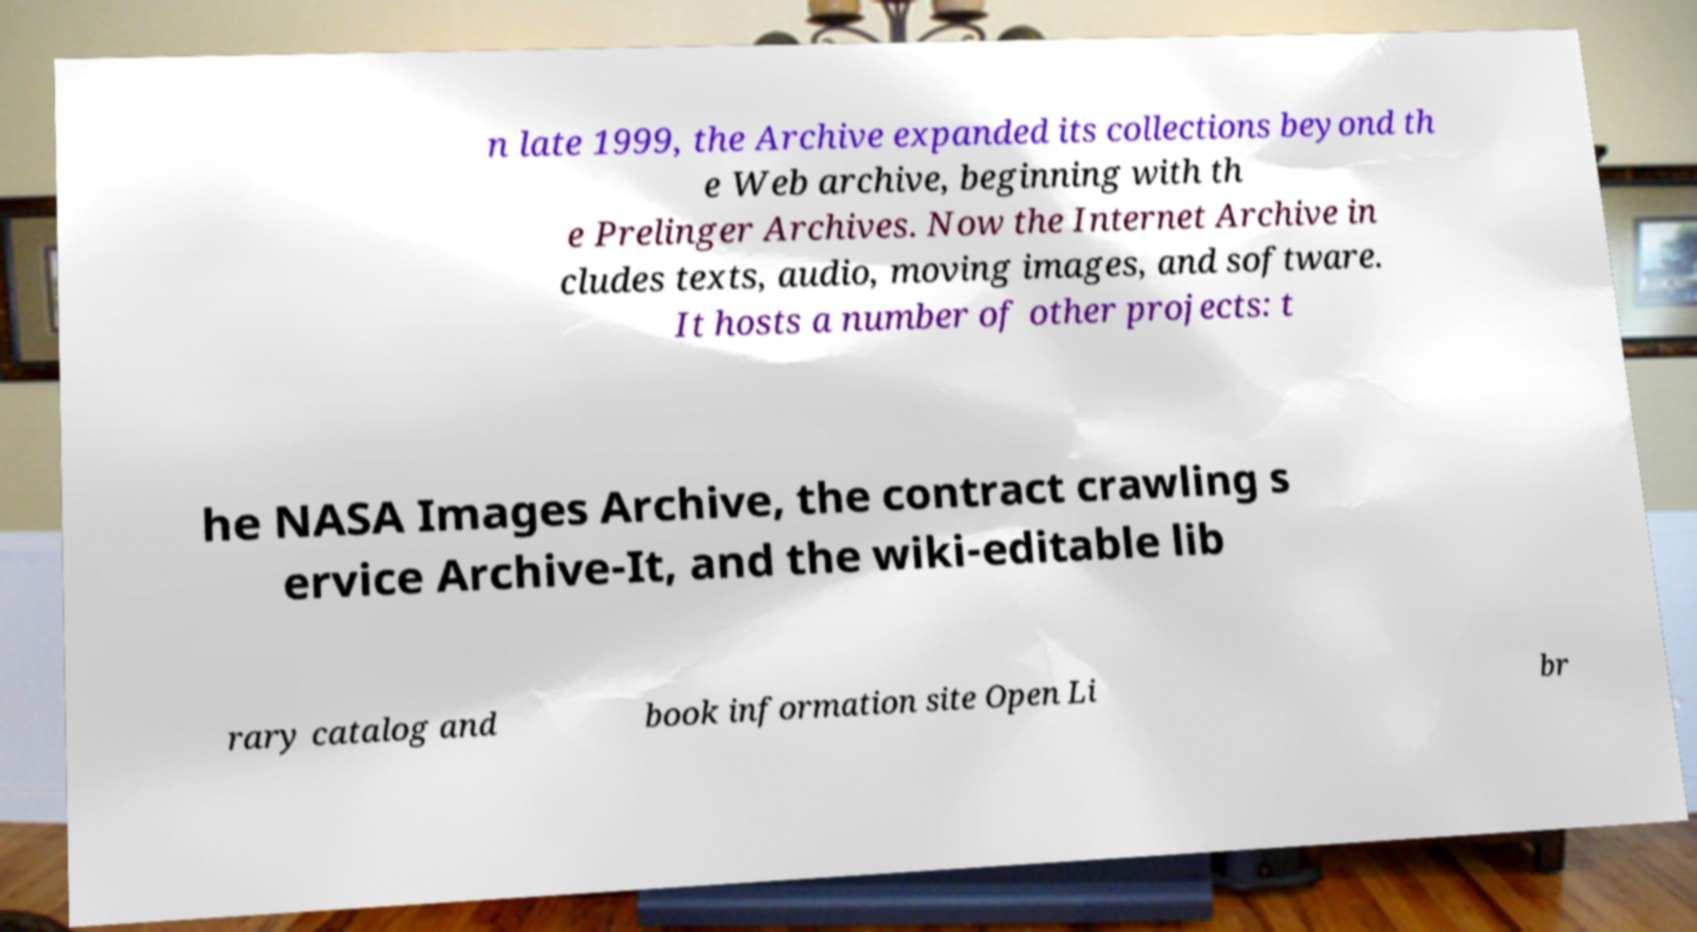Could you extract and type out the text from this image? n late 1999, the Archive expanded its collections beyond th e Web archive, beginning with th e Prelinger Archives. Now the Internet Archive in cludes texts, audio, moving images, and software. It hosts a number of other projects: t he NASA Images Archive, the contract crawling s ervice Archive-It, and the wiki-editable lib rary catalog and book information site Open Li br 